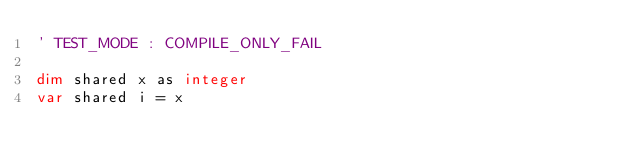Convert code to text. <code><loc_0><loc_0><loc_500><loc_500><_VisualBasic_>' TEST_MODE : COMPILE_ONLY_FAIL

dim shared x as integer
var shared i = x
</code> 